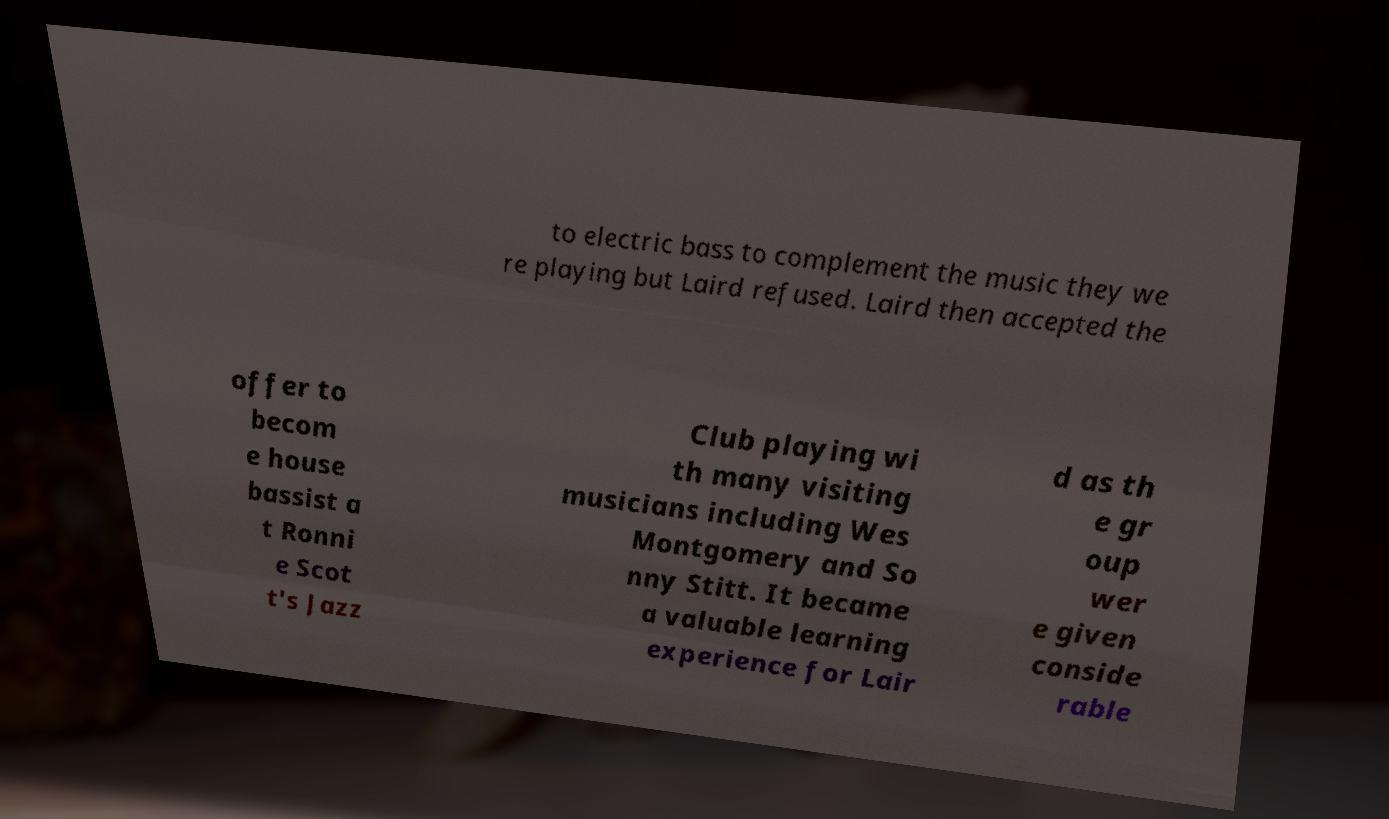What messages or text are displayed in this image? I need them in a readable, typed format. to electric bass to complement the music they we re playing but Laird refused. Laird then accepted the offer to becom e house bassist a t Ronni e Scot t's Jazz Club playing wi th many visiting musicians including Wes Montgomery and So nny Stitt. It became a valuable learning experience for Lair d as th e gr oup wer e given conside rable 